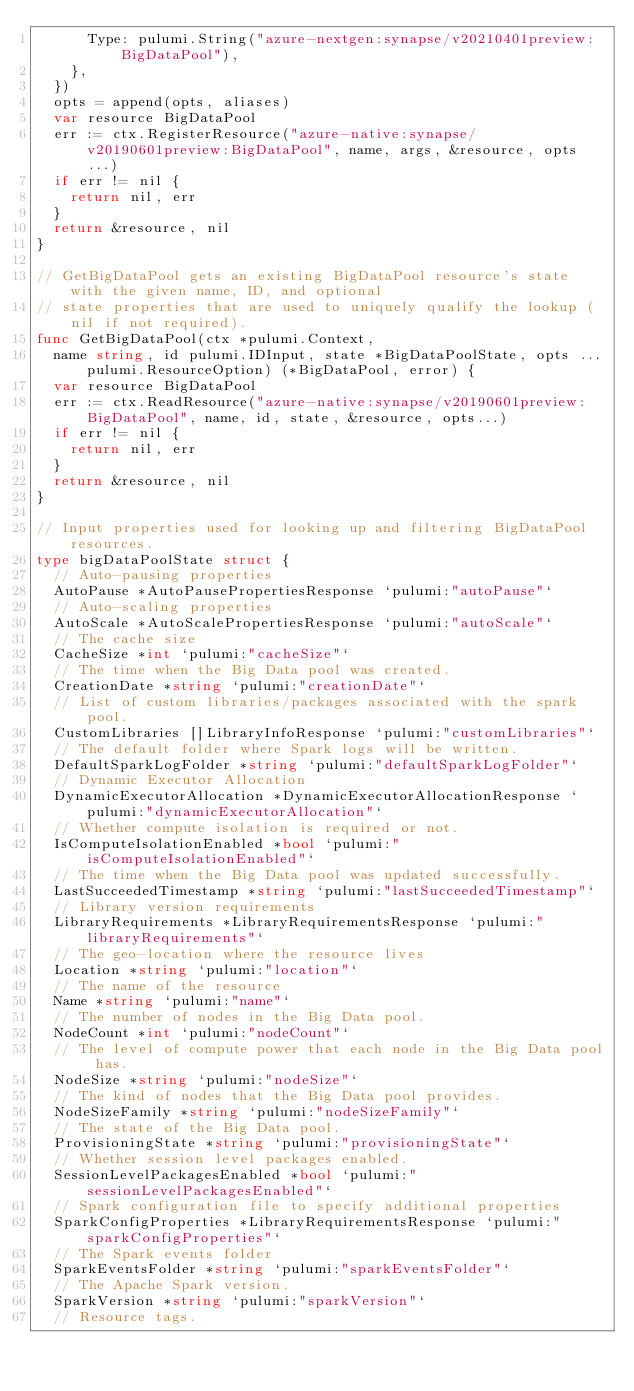Convert code to text. <code><loc_0><loc_0><loc_500><loc_500><_Go_>			Type: pulumi.String("azure-nextgen:synapse/v20210401preview:BigDataPool"),
		},
	})
	opts = append(opts, aliases)
	var resource BigDataPool
	err := ctx.RegisterResource("azure-native:synapse/v20190601preview:BigDataPool", name, args, &resource, opts...)
	if err != nil {
		return nil, err
	}
	return &resource, nil
}

// GetBigDataPool gets an existing BigDataPool resource's state with the given name, ID, and optional
// state properties that are used to uniquely qualify the lookup (nil if not required).
func GetBigDataPool(ctx *pulumi.Context,
	name string, id pulumi.IDInput, state *BigDataPoolState, opts ...pulumi.ResourceOption) (*BigDataPool, error) {
	var resource BigDataPool
	err := ctx.ReadResource("azure-native:synapse/v20190601preview:BigDataPool", name, id, state, &resource, opts...)
	if err != nil {
		return nil, err
	}
	return &resource, nil
}

// Input properties used for looking up and filtering BigDataPool resources.
type bigDataPoolState struct {
	// Auto-pausing properties
	AutoPause *AutoPausePropertiesResponse `pulumi:"autoPause"`
	// Auto-scaling properties
	AutoScale *AutoScalePropertiesResponse `pulumi:"autoScale"`
	// The cache size
	CacheSize *int `pulumi:"cacheSize"`
	// The time when the Big Data pool was created.
	CreationDate *string `pulumi:"creationDate"`
	// List of custom libraries/packages associated with the spark pool.
	CustomLibraries []LibraryInfoResponse `pulumi:"customLibraries"`
	// The default folder where Spark logs will be written.
	DefaultSparkLogFolder *string `pulumi:"defaultSparkLogFolder"`
	// Dynamic Executor Allocation
	DynamicExecutorAllocation *DynamicExecutorAllocationResponse `pulumi:"dynamicExecutorAllocation"`
	// Whether compute isolation is required or not.
	IsComputeIsolationEnabled *bool `pulumi:"isComputeIsolationEnabled"`
	// The time when the Big Data pool was updated successfully.
	LastSucceededTimestamp *string `pulumi:"lastSucceededTimestamp"`
	// Library version requirements
	LibraryRequirements *LibraryRequirementsResponse `pulumi:"libraryRequirements"`
	// The geo-location where the resource lives
	Location *string `pulumi:"location"`
	// The name of the resource
	Name *string `pulumi:"name"`
	// The number of nodes in the Big Data pool.
	NodeCount *int `pulumi:"nodeCount"`
	// The level of compute power that each node in the Big Data pool has.
	NodeSize *string `pulumi:"nodeSize"`
	// The kind of nodes that the Big Data pool provides.
	NodeSizeFamily *string `pulumi:"nodeSizeFamily"`
	// The state of the Big Data pool.
	ProvisioningState *string `pulumi:"provisioningState"`
	// Whether session level packages enabled.
	SessionLevelPackagesEnabled *bool `pulumi:"sessionLevelPackagesEnabled"`
	// Spark configuration file to specify additional properties
	SparkConfigProperties *LibraryRequirementsResponse `pulumi:"sparkConfigProperties"`
	// The Spark events folder
	SparkEventsFolder *string `pulumi:"sparkEventsFolder"`
	// The Apache Spark version.
	SparkVersion *string `pulumi:"sparkVersion"`
	// Resource tags.</code> 